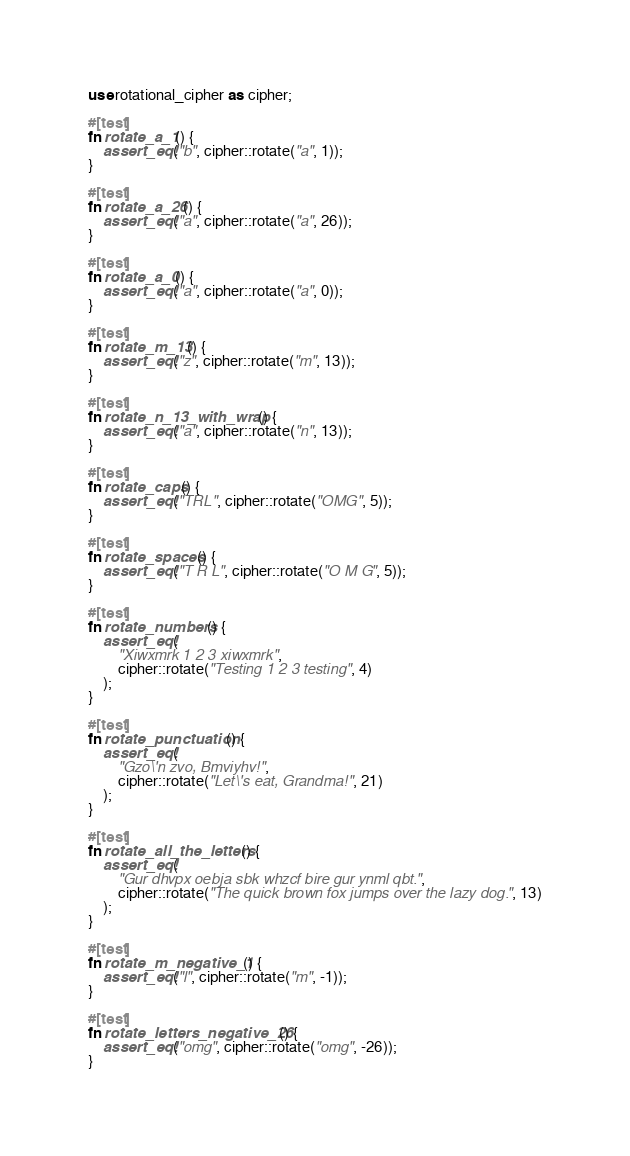Convert code to text. <code><loc_0><loc_0><loc_500><loc_500><_Rust_>use rotational_cipher as cipher;

#[test]
fn rotate_a_1() {
    assert_eq!("b", cipher::rotate("a", 1));
}

#[test]
fn rotate_a_26() {
    assert_eq!("a", cipher::rotate("a", 26));
}

#[test]
fn rotate_a_0() {
    assert_eq!("a", cipher::rotate("a", 0));
}

#[test]
fn rotate_m_13() {
    assert_eq!("z", cipher::rotate("m", 13));
}

#[test]
fn rotate_n_13_with_wrap() {
    assert_eq!("a", cipher::rotate("n", 13));
}

#[test]
fn rotate_caps() {
    assert_eq!("TRL", cipher::rotate("OMG", 5));
}

#[test]
fn rotate_spaces() {
    assert_eq!("T R L", cipher::rotate("O M G", 5));
}

#[test]
fn rotate_numbers() {
    assert_eq!(
        "Xiwxmrk 1 2 3 xiwxmrk",
        cipher::rotate("Testing 1 2 3 testing", 4)
    );
}

#[test]
fn rotate_punctuation() {
    assert_eq!(
        "Gzo\'n zvo, Bmviyhv!",
        cipher::rotate("Let\'s eat, Grandma!", 21)
    );
}

#[test]
fn rotate_all_the_letters() {
    assert_eq!(
        "Gur dhvpx oebja sbk whzcf bire gur ynml qbt.",
        cipher::rotate("The quick brown fox jumps over the lazy dog.", 13)
    );
}

#[test]
fn rotate_m_negative_1() {
    assert_eq!("l", cipher::rotate("m", -1));
}

#[test]
fn rotate_letters_negative_26() {
    assert_eq!("omg", cipher::rotate("omg", -26));
}
</code> 